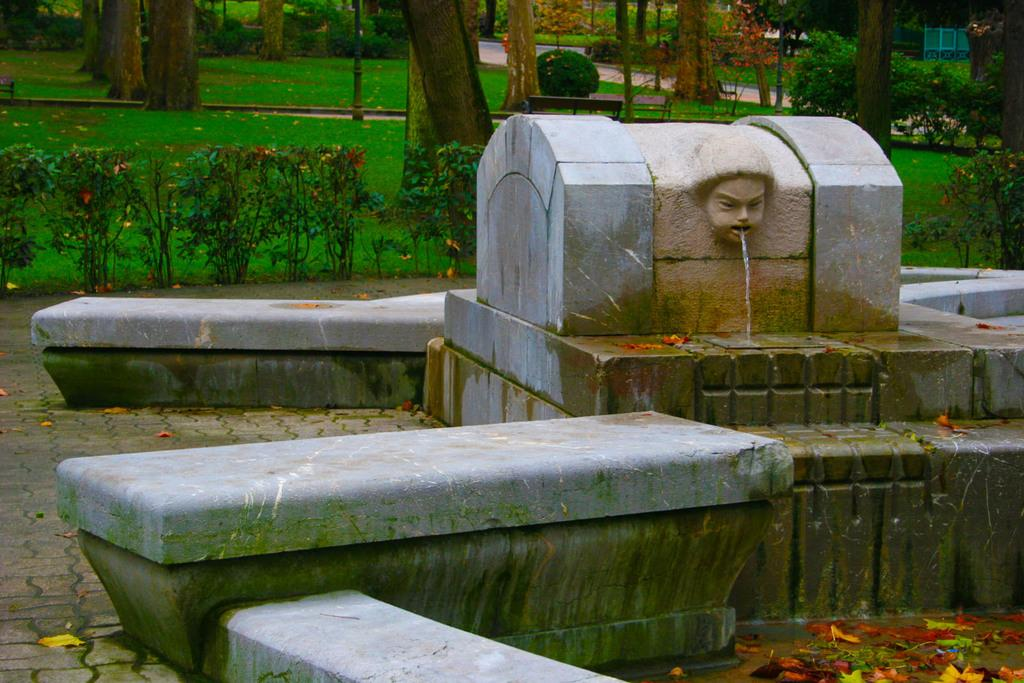What is the main feature of the sculpture in the image? Water is coming out of the sculpture in the image. What type of vegetation can be seen in the image? There are plants, grass, and trees visible in the image. What type of seating is present in the image? There is a bench in the image. How many fingers can be seen holding the berry in the image? There is no berry or fingers present in the image. What type of headwear is the person wearing in the image? There is no person or headwear present in the image. 